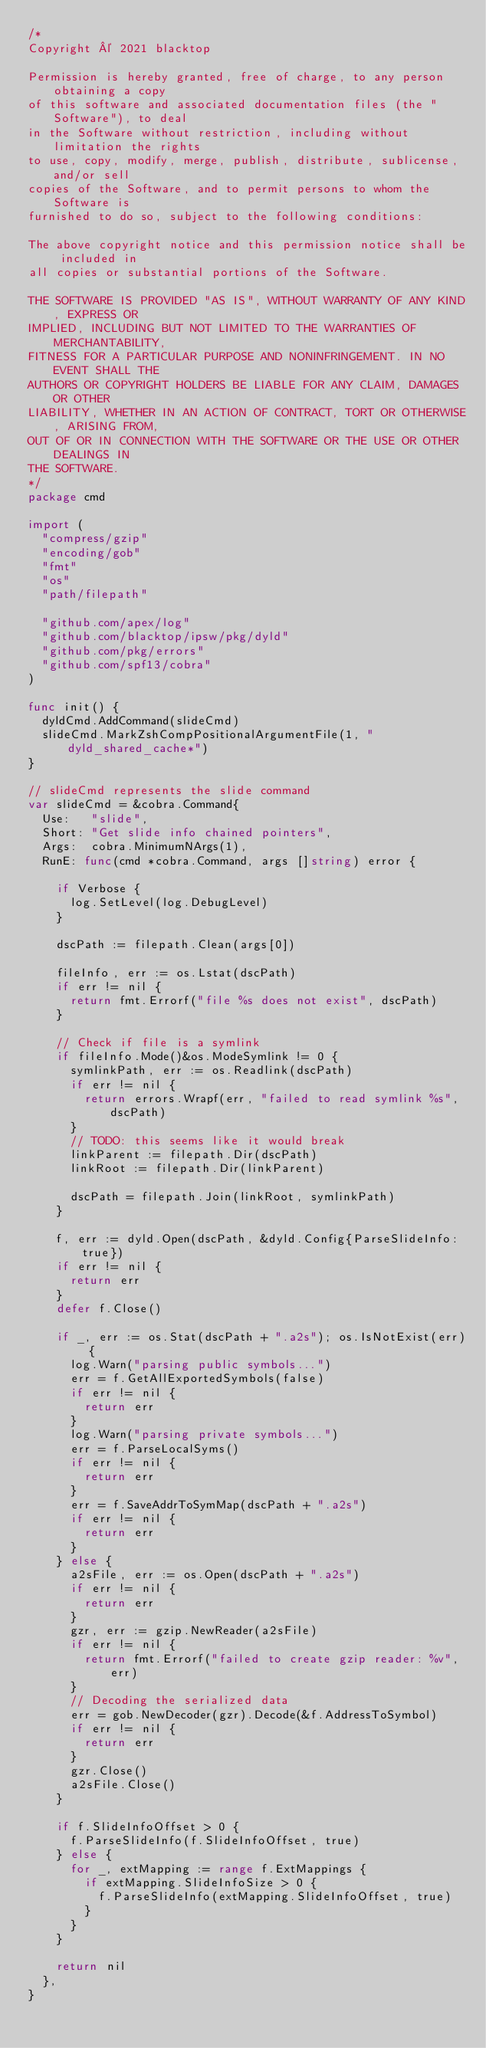<code> <loc_0><loc_0><loc_500><loc_500><_Go_>/*
Copyright © 2021 blacktop

Permission is hereby granted, free of charge, to any person obtaining a copy
of this software and associated documentation files (the "Software"), to deal
in the Software without restriction, including without limitation the rights
to use, copy, modify, merge, publish, distribute, sublicense, and/or sell
copies of the Software, and to permit persons to whom the Software is
furnished to do so, subject to the following conditions:

The above copyright notice and this permission notice shall be included in
all copies or substantial portions of the Software.

THE SOFTWARE IS PROVIDED "AS IS", WITHOUT WARRANTY OF ANY KIND, EXPRESS OR
IMPLIED, INCLUDING BUT NOT LIMITED TO THE WARRANTIES OF MERCHANTABILITY,
FITNESS FOR A PARTICULAR PURPOSE AND NONINFRINGEMENT. IN NO EVENT SHALL THE
AUTHORS OR COPYRIGHT HOLDERS BE LIABLE FOR ANY CLAIM, DAMAGES OR OTHER
LIABILITY, WHETHER IN AN ACTION OF CONTRACT, TORT OR OTHERWISE, ARISING FROM,
OUT OF OR IN CONNECTION WITH THE SOFTWARE OR THE USE OR OTHER DEALINGS IN
THE SOFTWARE.
*/
package cmd

import (
	"compress/gzip"
	"encoding/gob"
	"fmt"
	"os"
	"path/filepath"

	"github.com/apex/log"
	"github.com/blacktop/ipsw/pkg/dyld"
	"github.com/pkg/errors"
	"github.com/spf13/cobra"
)

func init() {
	dyldCmd.AddCommand(slideCmd)
	slideCmd.MarkZshCompPositionalArgumentFile(1, "dyld_shared_cache*")
}

// slideCmd represents the slide command
var slideCmd = &cobra.Command{
	Use:   "slide",
	Short: "Get slide info chained pointers",
	Args:  cobra.MinimumNArgs(1),
	RunE: func(cmd *cobra.Command, args []string) error {

		if Verbose {
			log.SetLevel(log.DebugLevel)
		}

		dscPath := filepath.Clean(args[0])

		fileInfo, err := os.Lstat(dscPath)
		if err != nil {
			return fmt.Errorf("file %s does not exist", dscPath)
		}

		// Check if file is a symlink
		if fileInfo.Mode()&os.ModeSymlink != 0 {
			symlinkPath, err := os.Readlink(dscPath)
			if err != nil {
				return errors.Wrapf(err, "failed to read symlink %s", dscPath)
			}
			// TODO: this seems like it would break
			linkParent := filepath.Dir(dscPath)
			linkRoot := filepath.Dir(linkParent)

			dscPath = filepath.Join(linkRoot, symlinkPath)
		}

		f, err := dyld.Open(dscPath, &dyld.Config{ParseSlideInfo: true})
		if err != nil {
			return err
		}
		defer f.Close()

		if _, err := os.Stat(dscPath + ".a2s"); os.IsNotExist(err) {
			log.Warn("parsing public symbols...")
			err = f.GetAllExportedSymbols(false)
			if err != nil {
				return err
			}
			log.Warn("parsing private symbols...")
			err = f.ParseLocalSyms()
			if err != nil {
				return err
			}
			err = f.SaveAddrToSymMap(dscPath + ".a2s")
			if err != nil {
				return err
			}
		} else {
			a2sFile, err := os.Open(dscPath + ".a2s")
			if err != nil {
				return err
			}
			gzr, err := gzip.NewReader(a2sFile)
			if err != nil {
				return fmt.Errorf("failed to create gzip reader: %v", err)
			}
			// Decoding the serialized data
			err = gob.NewDecoder(gzr).Decode(&f.AddressToSymbol)
			if err != nil {
				return err
			}
			gzr.Close()
			a2sFile.Close()
		}

		if f.SlideInfoOffset > 0 {
			f.ParseSlideInfo(f.SlideInfoOffset, true)
		} else {
			for _, extMapping := range f.ExtMappings {
				if extMapping.SlideInfoSize > 0 {
					f.ParseSlideInfo(extMapping.SlideInfoOffset, true)
				}
			}
		}

		return nil
	},
}
</code> 